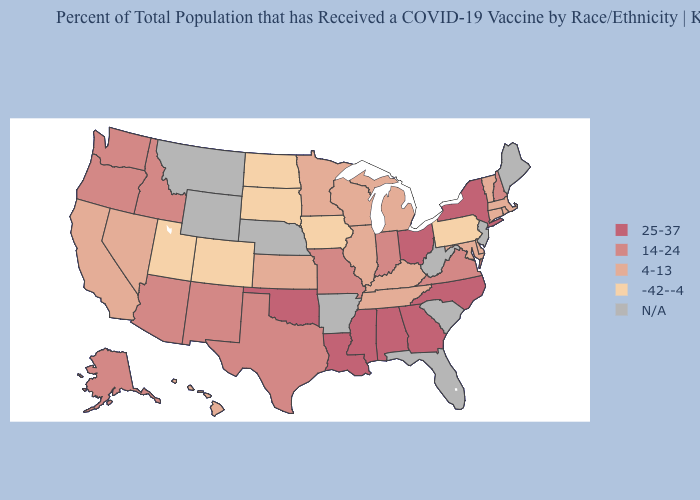What is the value of Nebraska?
Give a very brief answer. N/A. Does the map have missing data?
Quick response, please. Yes. What is the lowest value in the West?
Concise answer only. -42--4. What is the value of Virginia?
Give a very brief answer. 14-24. What is the value of Montana?
Be succinct. N/A. What is the lowest value in the USA?
Keep it brief. -42--4. What is the lowest value in the West?
Concise answer only. -42--4. What is the value of Iowa?
Short answer required. -42--4. Which states have the lowest value in the South?
Write a very short answer. Delaware, Kentucky, Maryland, Tennessee. What is the value of Kentucky?
Short answer required. 4-13. Which states hav the highest value in the MidWest?
Short answer required. Ohio. 